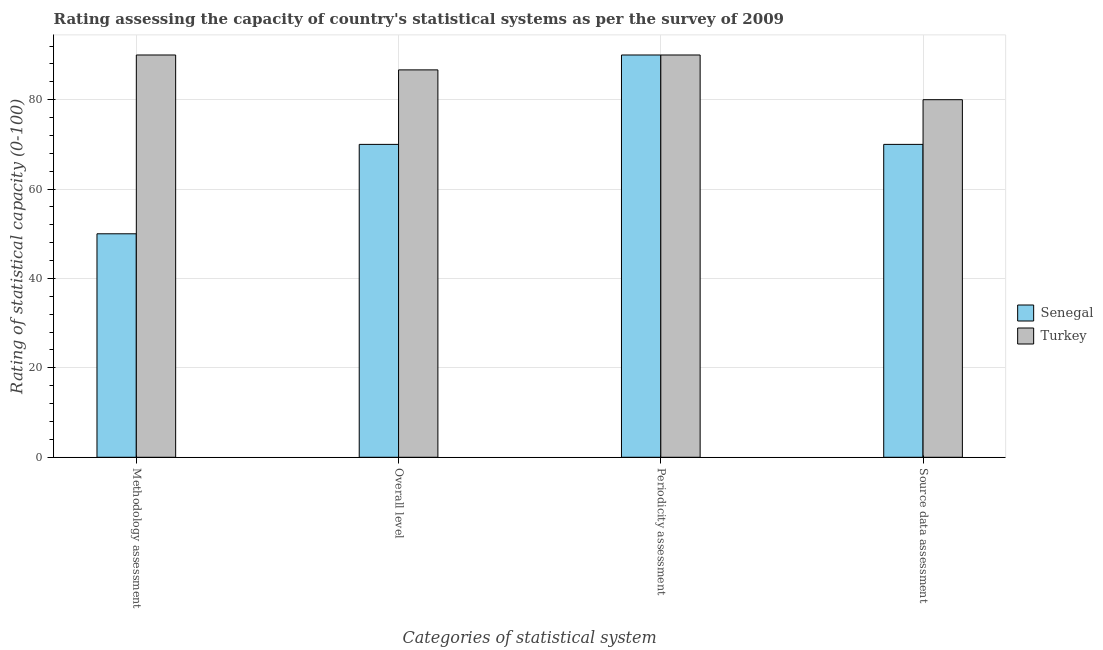How many different coloured bars are there?
Your answer should be compact. 2. Are the number of bars per tick equal to the number of legend labels?
Ensure brevity in your answer.  Yes. How many bars are there on the 2nd tick from the left?
Provide a succinct answer. 2. What is the label of the 3rd group of bars from the left?
Ensure brevity in your answer.  Periodicity assessment. Across all countries, what is the maximum methodology assessment rating?
Your answer should be compact. 90. Across all countries, what is the minimum methodology assessment rating?
Make the answer very short. 50. In which country was the methodology assessment rating maximum?
Make the answer very short. Turkey. In which country was the methodology assessment rating minimum?
Your answer should be compact. Senegal. What is the total periodicity assessment rating in the graph?
Make the answer very short. 180. What is the difference between the periodicity assessment rating in Senegal and that in Turkey?
Offer a very short reply. 0. What is the average source data assessment rating per country?
Offer a terse response. 75. Is the difference between the periodicity assessment rating in Turkey and Senegal greater than the difference between the methodology assessment rating in Turkey and Senegal?
Provide a succinct answer. No. What is the difference between the highest and the second highest source data assessment rating?
Offer a terse response. 10. What is the difference between the highest and the lowest periodicity assessment rating?
Your response must be concise. 0. In how many countries, is the overall level rating greater than the average overall level rating taken over all countries?
Your response must be concise. 1. What does the 2nd bar from the left in Periodicity assessment represents?
Provide a succinct answer. Turkey. What does the 2nd bar from the right in Methodology assessment represents?
Ensure brevity in your answer.  Senegal. Are all the bars in the graph horizontal?
Your answer should be compact. No. How many countries are there in the graph?
Offer a terse response. 2. Does the graph contain grids?
Keep it short and to the point. Yes. How are the legend labels stacked?
Make the answer very short. Vertical. What is the title of the graph?
Make the answer very short. Rating assessing the capacity of country's statistical systems as per the survey of 2009 . Does "Mauritania" appear as one of the legend labels in the graph?
Keep it short and to the point. No. What is the label or title of the X-axis?
Make the answer very short. Categories of statistical system. What is the label or title of the Y-axis?
Offer a terse response. Rating of statistical capacity (0-100). What is the Rating of statistical capacity (0-100) in Senegal in Methodology assessment?
Offer a terse response. 50. What is the Rating of statistical capacity (0-100) of Turkey in Methodology assessment?
Make the answer very short. 90. What is the Rating of statistical capacity (0-100) in Turkey in Overall level?
Keep it short and to the point. 86.67. What is the Rating of statistical capacity (0-100) of Turkey in Periodicity assessment?
Keep it short and to the point. 90. What is the Rating of statistical capacity (0-100) of Senegal in Source data assessment?
Keep it short and to the point. 70. What is the Rating of statistical capacity (0-100) in Turkey in Source data assessment?
Ensure brevity in your answer.  80. Across all Categories of statistical system, what is the minimum Rating of statistical capacity (0-100) of Senegal?
Provide a succinct answer. 50. Across all Categories of statistical system, what is the minimum Rating of statistical capacity (0-100) in Turkey?
Your answer should be very brief. 80. What is the total Rating of statistical capacity (0-100) in Senegal in the graph?
Give a very brief answer. 280. What is the total Rating of statistical capacity (0-100) in Turkey in the graph?
Provide a short and direct response. 346.67. What is the difference between the Rating of statistical capacity (0-100) of Senegal in Methodology assessment and that in Periodicity assessment?
Keep it short and to the point. -40. What is the difference between the Rating of statistical capacity (0-100) of Turkey in Methodology assessment and that in Periodicity assessment?
Your answer should be very brief. 0. What is the difference between the Rating of statistical capacity (0-100) of Senegal in Methodology assessment and that in Source data assessment?
Provide a short and direct response. -20. What is the difference between the Rating of statistical capacity (0-100) in Turkey in Methodology assessment and that in Source data assessment?
Ensure brevity in your answer.  10. What is the difference between the Rating of statistical capacity (0-100) of Senegal in Periodicity assessment and that in Source data assessment?
Make the answer very short. 20. What is the difference between the Rating of statistical capacity (0-100) of Turkey in Periodicity assessment and that in Source data assessment?
Your answer should be compact. 10. What is the difference between the Rating of statistical capacity (0-100) of Senegal in Methodology assessment and the Rating of statistical capacity (0-100) of Turkey in Overall level?
Give a very brief answer. -36.67. What is the difference between the Rating of statistical capacity (0-100) in Senegal in Methodology assessment and the Rating of statistical capacity (0-100) in Turkey in Periodicity assessment?
Give a very brief answer. -40. What is the difference between the Rating of statistical capacity (0-100) in Senegal in Overall level and the Rating of statistical capacity (0-100) in Turkey in Periodicity assessment?
Give a very brief answer. -20. What is the average Rating of statistical capacity (0-100) in Senegal per Categories of statistical system?
Provide a short and direct response. 70. What is the average Rating of statistical capacity (0-100) of Turkey per Categories of statistical system?
Your response must be concise. 86.67. What is the difference between the Rating of statistical capacity (0-100) of Senegal and Rating of statistical capacity (0-100) of Turkey in Overall level?
Give a very brief answer. -16.67. What is the difference between the Rating of statistical capacity (0-100) of Senegal and Rating of statistical capacity (0-100) of Turkey in Periodicity assessment?
Keep it short and to the point. 0. What is the difference between the Rating of statistical capacity (0-100) of Senegal and Rating of statistical capacity (0-100) of Turkey in Source data assessment?
Offer a terse response. -10. What is the ratio of the Rating of statistical capacity (0-100) in Senegal in Methodology assessment to that in Overall level?
Offer a terse response. 0.71. What is the ratio of the Rating of statistical capacity (0-100) of Turkey in Methodology assessment to that in Overall level?
Offer a very short reply. 1.04. What is the ratio of the Rating of statistical capacity (0-100) in Senegal in Methodology assessment to that in Periodicity assessment?
Make the answer very short. 0.56. What is the ratio of the Rating of statistical capacity (0-100) in Senegal in Methodology assessment to that in Source data assessment?
Your answer should be compact. 0.71. What is the ratio of the Rating of statistical capacity (0-100) in Turkey in Methodology assessment to that in Source data assessment?
Offer a terse response. 1.12. What is the ratio of the Rating of statistical capacity (0-100) in Turkey in Overall level to that in Periodicity assessment?
Keep it short and to the point. 0.96. What is the ratio of the Rating of statistical capacity (0-100) of Senegal in Overall level to that in Source data assessment?
Offer a terse response. 1. What is the ratio of the Rating of statistical capacity (0-100) in Turkey in Overall level to that in Source data assessment?
Provide a short and direct response. 1.08. What is the ratio of the Rating of statistical capacity (0-100) of Turkey in Periodicity assessment to that in Source data assessment?
Offer a terse response. 1.12. What is the difference between the highest and the lowest Rating of statistical capacity (0-100) of Senegal?
Your response must be concise. 40. What is the difference between the highest and the lowest Rating of statistical capacity (0-100) of Turkey?
Give a very brief answer. 10. 